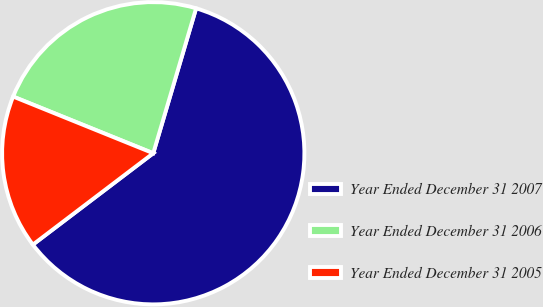Convert chart to OTSL. <chart><loc_0><loc_0><loc_500><loc_500><pie_chart><fcel>Year Ended December 31 2007<fcel>Year Ended December 31 2006<fcel>Year Ended December 31 2005<nl><fcel>60.09%<fcel>23.46%<fcel>16.45%<nl></chart> 